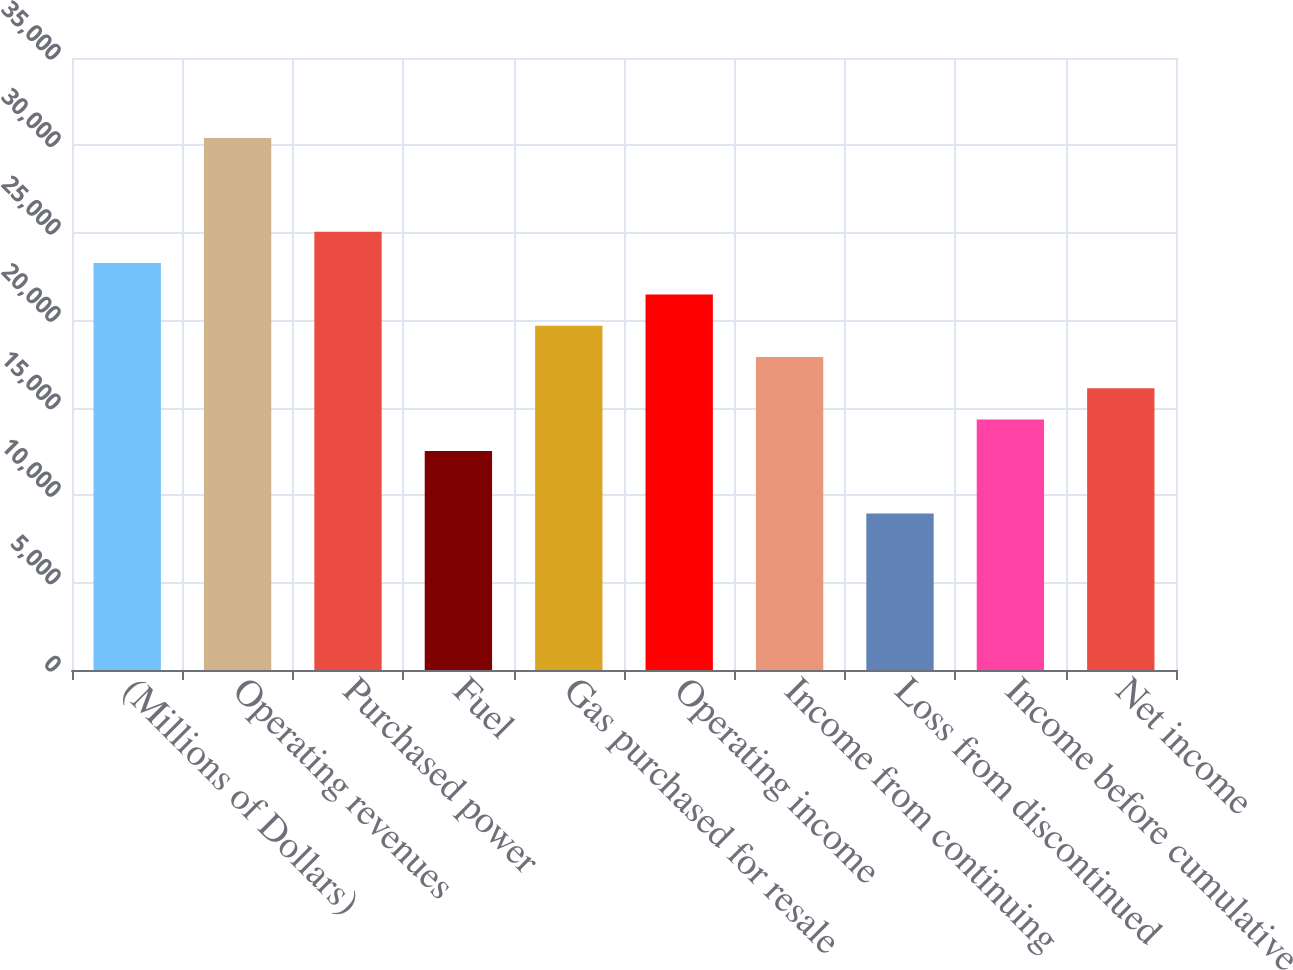<chart> <loc_0><loc_0><loc_500><loc_500><bar_chart><fcel>(Millions of Dollars)<fcel>Operating revenues<fcel>Purchased power<fcel>Fuel<fcel>Gas purchased for resale<fcel>Operating income<fcel>Income from continuing<fcel>Loss from discontinued<fcel>Income before cumulative<fcel>Net income<nl><fcel>23271.2<fcel>30431.6<fcel>25061.3<fcel>12530.7<fcel>19691<fcel>21481.1<fcel>17901<fcel>8950.51<fcel>14320.8<fcel>16110.9<nl></chart> 